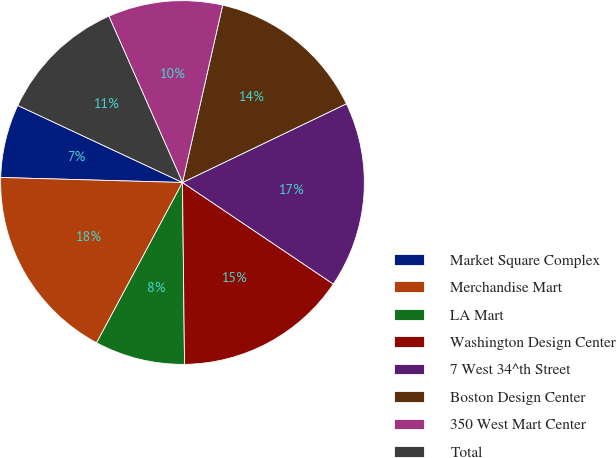<chart> <loc_0><loc_0><loc_500><loc_500><pie_chart><fcel>Market Square Complex<fcel>Merchandise Mart<fcel>LA Mart<fcel>Washington Design Center<fcel>7 West 34^th Street<fcel>Boston Design Center<fcel>350 West Mart Center<fcel>Total<nl><fcel>6.53%<fcel>17.61%<fcel>8.01%<fcel>15.39%<fcel>16.56%<fcel>14.33%<fcel>10.18%<fcel>11.4%<nl></chart> 